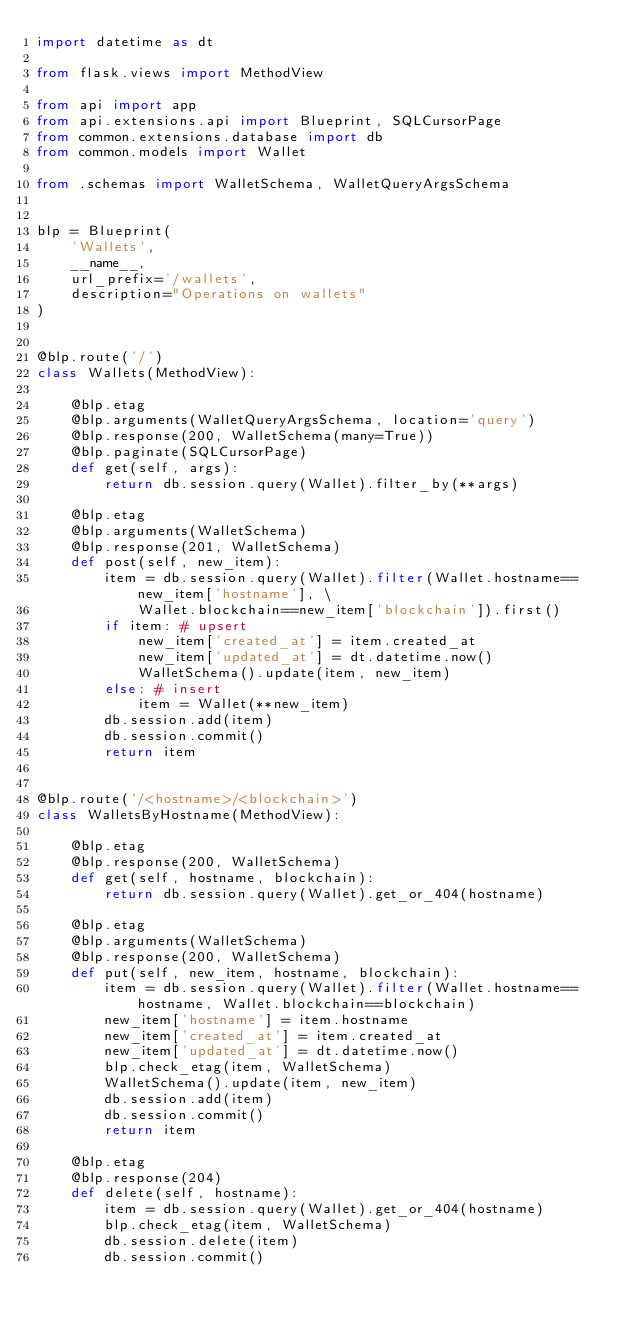<code> <loc_0><loc_0><loc_500><loc_500><_Python_>import datetime as dt

from flask.views import MethodView

from api import app
from api.extensions.api import Blueprint, SQLCursorPage
from common.extensions.database import db
from common.models import Wallet

from .schemas import WalletSchema, WalletQueryArgsSchema


blp = Blueprint(
    'Wallets',
    __name__,
    url_prefix='/wallets',
    description="Operations on wallets"
)


@blp.route('/')
class Wallets(MethodView):

    @blp.etag
    @blp.arguments(WalletQueryArgsSchema, location='query')
    @blp.response(200, WalletSchema(many=True))
    @blp.paginate(SQLCursorPage)
    def get(self, args):
        return db.session.query(Wallet).filter_by(**args)

    @blp.etag
    @blp.arguments(WalletSchema)
    @blp.response(201, WalletSchema)
    def post(self, new_item):
        item = db.session.query(Wallet).filter(Wallet.hostname==new_item['hostname'], \
            Wallet.blockchain==new_item['blockchain']).first()
        if item: # upsert
            new_item['created_at'] = item.created_at
            new_item['updated_at'] = dt.datetime.now()
            WalletSchema().update(item, new_item)
        else: # insert
            item = Wallet(**new_item)
        db.session.add(item)
        db.session.commit()
        return item


@blp.route('/<hostname>/<blockchain>')
class WalletsByHostname(MethodView):

    @blp.etag
    @blp.response(200, WalletSchema)
    def get(self, hostname, blockchain):
        return db.session.query(Wallet).get_or_404(hostname)

    @blp.etag
    @blp.arguments(WalletSchema)
    @blp.response(200, WalletSchema)
    def put(self, new_item, hostname, blockchain):
        item = db.session.query(Wallet).filter(Wallet.hostname==hostname, Wallet.blockchain==blockchain)
        new_item['hostname'] = item.hostname
        new_item['created_at'] = item.created_at
        new_item['updated_at'] = dt.datetime.now()
        blp.check_etag(item, WalletSchema)
        WalletSchema().update(item, new_item)
        db.session.add(item)
        db.session.commit()
        return item

    @blp.etag
    @blp.response(204)
    def delete(self, hostname):
        item = db.session.query(Wallet).get_or_404(hostname)
        blp.check_etag(item, WalletSchema)
        db.session.delete(item)
        db.session.commit()</code> 